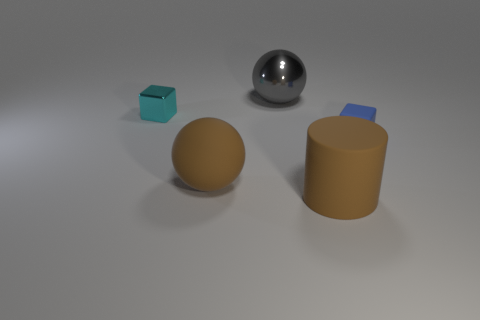There is a matte cylinder that is on the right side of the brown rubber sphere; is it the same color as the small thing that is to the right of the brown rubber ball?
Your answer should be compact. No. The matte cylinder that is the same size as the gray metallic ball is what color?
Keep it short and to the point. Brown. Is there a small shiny cube that has the same color as the big metal sphere?
Give a very brief answer. No. Does the brown matte thing that is behind the cylinder have the same size as the tiny cyan shiny cube?
Ensure brevity in your answer.  No. Are there an equal number of cyan objects that are to the right of the tiny metal object and matte balls?
Provide a short and direct response. No. How many objects are either rubber things that are right of the gray shiny object or gray shiny spheres?
Offer a terse response. 3. What is the shape of the large object that is both to the right of the brown matte ball and in front of the cyan thing?
Your answer should be very brief. Cylinder. How many things are either objects that are to the right of the small cyan thing or small things that are left of the big cylinder?
Provide a short and direct response. 5. How many other things are the same size as the matte sphere?
Offer a very short reply. 2. There is a big object behind the brown ball; is its color the same as the big rubber cylinder?
Keep it short and to the point. No. 